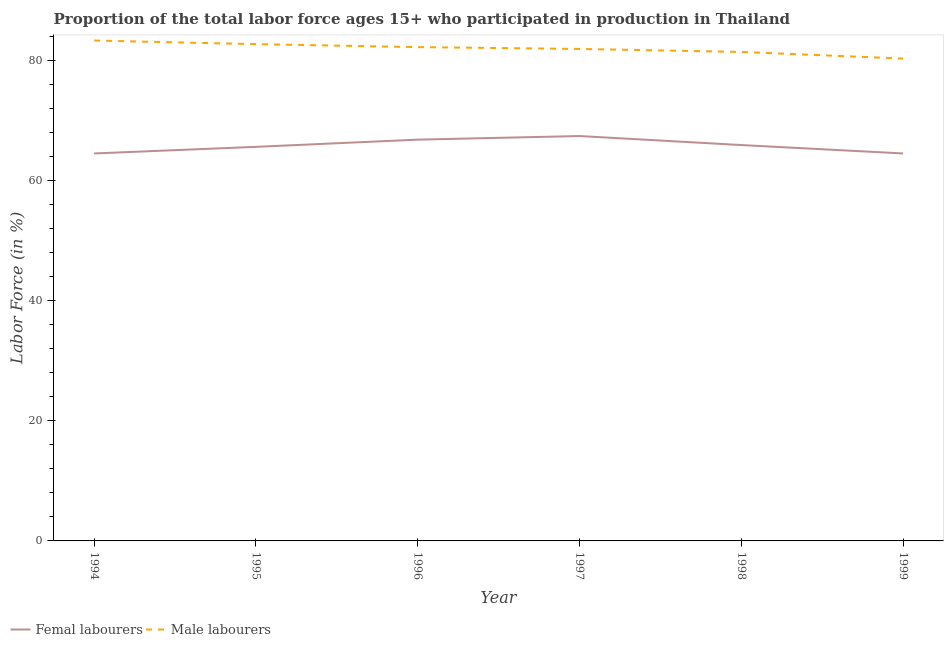How many different coloured lines are there?
Your response must be concise. 2. Does the line corresponding to percentage of female labor force intersect with the line corresponding to percentage of male labour force?
Give a very brief answer. No. Is the number of lines equal to the number of legend labels?
Your response must be concise. Yes. What is the percentage of female labor force in 1998?
Give a very brief answer. 65.9. Across all years, what is the maximum percentage of female labor force?
Give a very brief answer. 67.4. Across all years, what is the minimum percentage of female labor force?
Offer a very short reply. 64.5. In which year was the percentage of female labor force maximum?
Provide a short and direct response. 1997. In which year was the percentage of male labour force minimum?
Provide a short and direct response. 1999. What is the total percentage of male labour force in the graph?
Ensure brevity in your answer.  491.8. What is the difference between the percentage of female labor force in 1994 and that in 1996?
Keep it short and to the point. -2.3. What is the difference between the percentage of female labor force in 1999 and the percentage of male labour force in 1994?
Make the answer very short. -18.8. What is the average percentage of female labor force per year?
Offer a terse response. 65.78. In the year 1995, what is the difference between the percentage of female labor force and percentage of male labour force?
Make the answer very short. -17.1. What is the ratio of the percentage of female labor force in 1997 to that in 1998?
Ensure brevity in your answer.  1.02. What is the difference between the highest and the second highest percentage of male labour force?
Give a very brief answer. 0.6. What is the difference between the highest and the lowest percentage of female labor force?
Offer a very short reply. 2.9. In how many years, is the percentage of female labor force greater than the average percentage of female labor force taken over all years?
Offer a very short reply. 3. Is the sum of the percentage of male labour force in 1997 and 1998 greater than the maximum percentage of female labor force across all years?
Offer a very short reply. Yes. Is the percentage of female labor force strictly less than the percentage of male labour force over the years?
Offer a very short reply. Yes. What is the difference between two consecutive major ticks on the Y-axis?
Offer a terse response. 20. Are the values on the major ticks of Y-axis written in scientific E-notation?
Keep it short and to the point. No. Does the graph contain grids?
Give a very brief answer. No. Where does the legend appear in the graph?
Provide a short and direct response. Bottom left. How are the legend labels stacked?
Your answer should be very brief. Horizontal. What is the title of the graph?
Offer a very short reply. Proportion of the total labor force ages 15+ who participated in production in Thailand. What is the label or title of the X-axis?
Give a very brief answer. Year. What is the Labor Force (in %) of Femal labourers in 1994?
Give a very brief answer. 64.5. What is the Labor Force (in %) in Male labourers in 1994?
Offer a very short reply. 83.3. What is the Labor Force (in %) of Femal labourers in 1995?
Provide a short and direct response. 65.6. What is the Labor Force (in %) in Male labourers in 1995?
Your answer should be compact. 82.7. What is the Labor Force (in %) in Femal labourers in 1996?
Ensure brevity in your answer.  66.8. What is the Labor Force (in %) in Male labourers in 1996?
Give a very brief answer. 82.2. What is the Labor Force (in %) of Femal labourers in 1997?
Keep it short and to the point. 67.4. What is the Labor Force (in %) in Male labourers in 1997?
Provide a short and direct response. 81.9. What is the Labor Force (in %) in Femal labourers in 1998?
Your answer should be compact. 65.9. What is the Labor Force (in %) in Male labourers in 1998?
Offer a terse response. 81.4. What is the Labor Force (in %) in Femal labourers in 1999?
Your response must be concise. 64.5. What is the Labor Force (in %) of Male labourers in 1999?
Offer a terse response. 80.3. Across all years, what is the maximum Labor Force (in %) of Femal labourers?
Your answer should be compact. 67.4. Across all years, what is the maximum Labor Force (in %) in Male labourers?
Your response must be concise. 83.3. Across all years, what is the minimum Labor Force (in %) in Femal labourers?
Your response must be concise. 64.5. Across all years, what is the minimum Labor Force (in %) of Male labourers?
Your answer should be very brief. 80.3. What is the total Labor Force (in %) of Femal labourers in the graph?
Give a very brief answer. 394.7. What is the total Labor Force (in %) of Male labourers in the graph?
Provide a short and direct response. 491.8. What is the difference between the Labor Force (in %) in Femal labourers in 1994 and that in 1996?
Offer a terse response. -2.3. What is the difference between the Labor Force (in %) of Male labourers in 1994 and that in 1997?
Your response must be concise. 1.4. What is the difference between the Labor Force (in %) of Femal labourers in 1994 and that in 1998?
Offer a very short reply. -1.4. What is the difference between the Labor Force (in %) of Male labourers in 1994 and that in 1998?
Your response must be concise. 1.9. What is the difference between the Labor Force (in %) in Femal labourers in 1994 and that in 1999?
Offer a very short reply. 0. What is the difference between the Labor Force (in %) in Male labourers in 1994 and that in 1999?
Offer a very short reply. 3. What is the difference between the Labor Force (in %) in Femal labourers in 1995 and that in 1996?
Your answer should be compact. -1.2. What is the difference between the Labor Force (in %) of Male labourers in 1995 and that in 1996?
Provide a succinct answer. 0.5. What is the difference between the Labor Force (in %) in Femal labourers in 1995 and that in 1997?
Your answer should be very brief. -1.8. What is the difference between the Labor Force (in %) of Male labourers in 1995 and that in 1999?
Make the answer very short. 2.4. What is the difference between the Labor Force (in %) in Femal labourers in 1996 and that in 1997?
Your response must be concise. -0.6. What is the difference between the Labor Force (in %) of Male labourers in 1996 and that in 1997?
Provide a succinct answer. 0.3. What is the difference between the Labor Force (in %) in Femal labourers in 1996 and that in 1998?
Ensure brevity in your answer.  0.9. What is the difference between the Labor Force (in %) in Male labourers in 1996 and that in 1998?
Give a very brief answer. 0.8. What is the difference between the Labor Force (in %) of Femal labourers in 1997 and that in 1998?
Offer a very short reply. 1.5. What is the difference between the Labor Force (in %) in Femal labourers in 1997 and that in 1999?
Provide a succinct answer. 2.9. What is the difference between the Labor Force (in %) in Femal labourers in 1994 and the Labor Force (in %) in Male labourers in 1995?
Offer a very short reply. -18.2. What is the difference between the Labor Force (in %) of Femal labourers in 1994 and the Labor Force (in %) of Male labourers in 1996?
Keep it short and to the point. -17.7. What is the difference between the Labor Force (in %) in Femal labourers in 1994 and the Labor Force (in %) in Male labourers in 1997?
Ensure brevity in your answer.  -17.4. What is the difference between the Labor Force (in %) of Femal labourers in 1994 and the Labor Force (in %) of Male labourers in 1998?
Your response must be concise. -16.9. What is the difference between the Labor Force (in %) of Femal labourers in 1994 and the Labor Force (in %) of Male labourers in 1999?
Your answer should be compact. -15.8. What is the difference between the Labor Force (in %) of Femal labourers in 1995 and the Labor Force (in %) of Male labourers in 1996?
Offer a terse response. -16.6. What is the difference between the Labor Force (in %) of Femal labourers in 1995 and the Labor Force (in %) of Male labourers in 1997?
Give a very brief answer. -16.3. What is the difference between the Labor Force (in %) of Femal labourers in 1995 and the Labor Force (in %) of Male labourers in 1998?
Give a very brief answer. -15.8. What is the difference between the Labor Force (in %) of Femal labourers in 1995 and the Labor Force (in %) of Male labourers in 1999?
Your response must be concise. -14.7. What is the difference between the Labor Force (in %) in Femal labourers in 1996 and the Labor Force (in %) in Male labourers in 1997?
Offer a very short reply. -15.1. What is the difference between the Labor Force (in %) in Femal labourers in 1996 and the Labor Force (in %) in Male labourers in 1998?
Your answer should be very brief. -14.6. What is the difference between the Labor Force (in %) of Femal labourers in 1996 and the Labor Force (in %) of Male labourers in 1999?
Your response must be concise. -13.5. What is the difference between the Labor Force (in %) of Femal labourers in 1998 and the Labor Force (in %) of Male labourers in 1999?
Provide a short and direct response. -14.4. What is the average Labor Force (in %) of Femal labourers per year?
Keep it short and to the point. 65.78. What is the average Labor Force (in %) of Male labourers per year?
Your answer should be compact. 81.97. In the year 1994, what is the difference between the Labor Force (in %) of Femal labourers and Labor Force (in %) of Male labourers?
Offer a very short reply. -18.8. In the year 1995, what is the difference between the Labor Force (in %) in Femal labourers and Labor Force (in %) in Male labourers?
Provide a short and direct response. -17.1. In the year 1996, what is the difference between the Labor Force (in %) in Femal labourers and Labor Force (in %) in Male labourers?
Offer a terse response. -15.4. In the year 1998, what is the difference between the Labor Force (in %) in Femal labourers and Labor Force (in %) in Male labourers?
Ensure brevity in your answer.  -15.5. In the year 1999, what is the difference between the Labor Force (in %) in Femal labourers and Labor Force (in %) in Male labourers?
Provide a succinct answer. -15.8. What is the ratio of the Labor Force (in %) in Femal labourers in 1994 to that in 1995?
Give a very brief answer. 0.98. What is the ratio of the Labor Force (in %) of Male labourers in 1994 to that in 1995?
Give a very brief answer. 1.01. What is the ratio of the Labor Force (in %) of Femal labourers in 1994 to that in 1996?
Provide a short and direct response. 0.97. What is the ratio of the Labor Force (in %) of Male labourers in 1994 to that in 1996?
Offer a very short reply. 1.01. What is the ratio of the Labor Force (in %) of Male labourers in 1994 to that in 1997?
Give a very brief answer. 1.02. What is the ratio of the Labor Force (in %) in Femal labourers in 1994 to that in 1998?
Your response must be concise. 0.98. What is the ratio of the Labor Force (in %) in Male labourers in 1994 to that in 1998?
Ensure brevity in your answer.  1.02. What is the ratio of the Labor Force (in %) in Male labourers in 1994 to that in 1999?
Ensure brevity in your answer.  1.04. What is the ratio of the Labor Force (in %) of Male labourers in 1995 to that in 1996?
Your answer should be compact. 1.01. What is the ratio of the Labor Force (in %) of Femal labourers in 1995 to that in 1997?
Provide a short and direct response. 0.97. What is the ratio of the Labor Force (in %) of Male labourers in 1995 to that in 1997?
Give a very brief answer. 1.01. What is the ratio of the Labor Force (in %) in Male labourers in 1995 to that in 1998?
Offer a terse response. 1.02. What is the ratio of the Labor Force (in %) in Femal labourers in 1995 to that in 1999?
Your response must be concise. 1.02. What is the ratio of the Labor Force (in %) in Male labourers in 1995 to that in 1999?
Your answer should be compact. 1.03. What is the ratio of the Labor Force (in %) of Femal labourers in 1996 to that in 1997?
Offer a very short reply. 0.99. What is the ratio of the Labor Force (in %) of Male labourers in 1996 to that in 1997?
Give a very brief answer. 1. What is the ratio of the Labor Force (in %) in Femal labourers in 1996 to that in 1998?
Give a very brief answer. 1.01. What is the ratio of the Labor Force (in %) of Male labourers in 1996 to that in 1998?
Offer a very short reply. 1.01. What is the ratio of the Labor Force (in %) of Femal labourers in 1996 to that in 1999?
Your response must be concise. 1.04. What is the ratio of the Labor Force (in %) of Male labourers in 1996 to that in 1999?
Make the answer very short. 1.02. What is the ratio of the Labor Force (in %) in Femal labourers in 1997 to that in 1998?
Keep it short and to the point. 1.02. What is the ratio of the Labor Force (in %) of Femal labourers in 1997 to that in 1999?
Your answer should be compact. 1.04. What is the ratio of the Labor Force (in %) in Male labourers in 1997 to that in 1999?
Your answer should be very brief. 1.02. What is the ratio of the Labor Force (in %) in Femal labourers in 1998 to that in 1999?
Your response must be concise. 1.02. What is the ratio of the Labor Force (in %) of Male labourers in 1998 to that in 1999?
Keep it short and to the point. 1.01. What is the difference between the highest and the lowest Labor Force (in %) of Male labourers?
Offer a terse response. 3. 